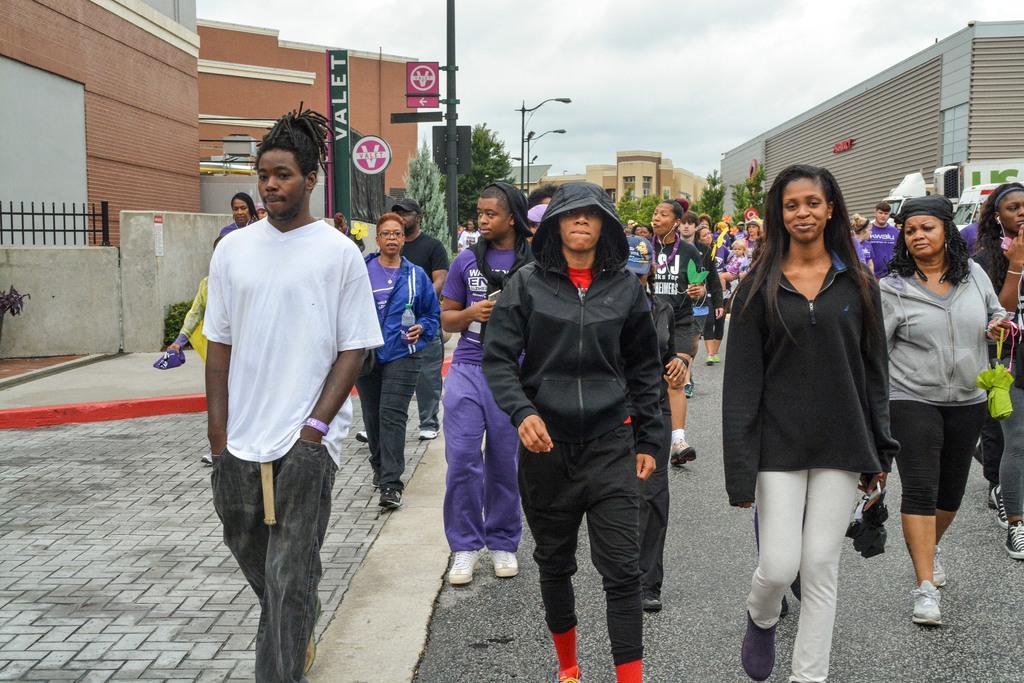Describe this image in one or two sentences. In this picture there are group of people walking on the road and we can see vehicles, wall, fence, boards and lights on poles. In the background of the image we can see buildings, trees and sky. 